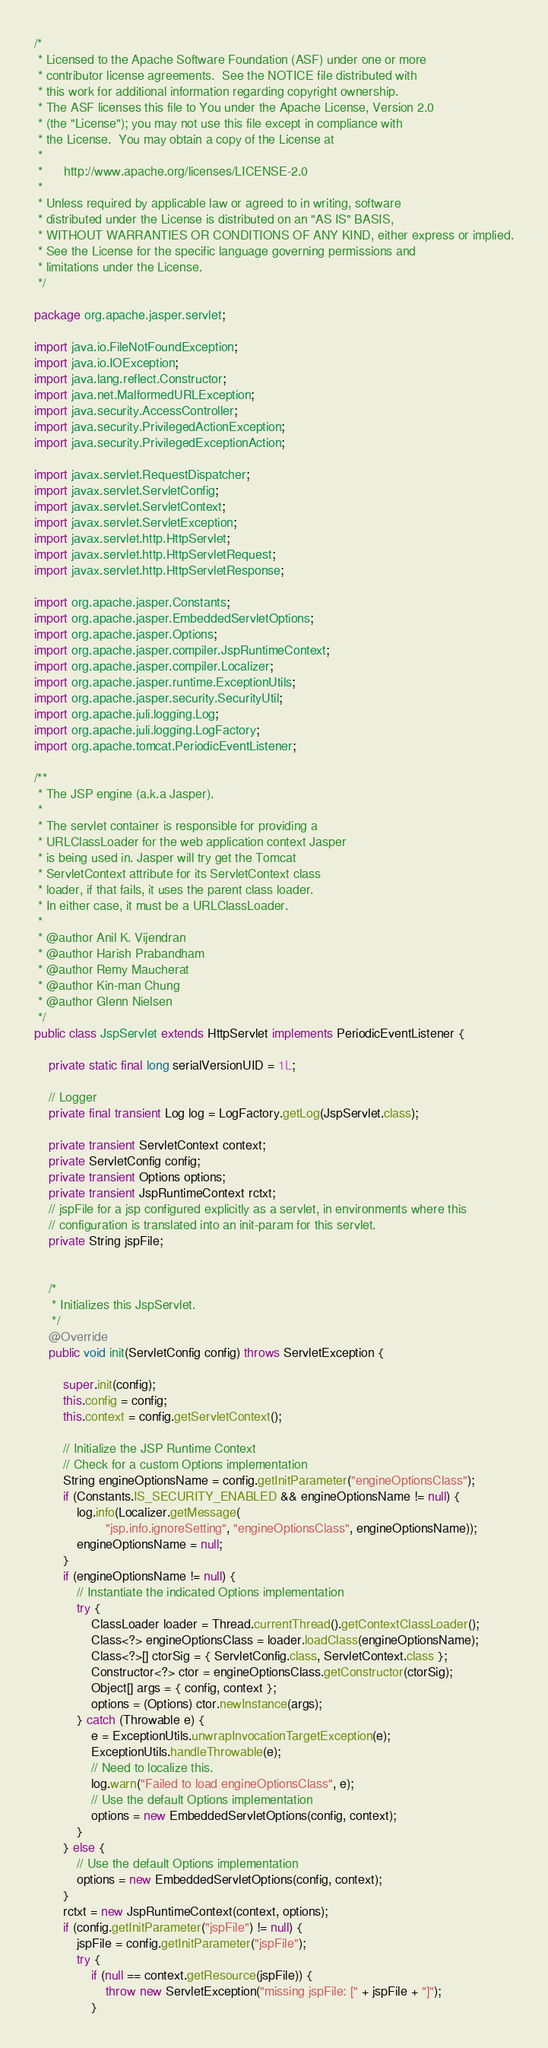<code> <loc_0><loc_0><loc_500><loc_500><_Java_>/*
 * Licensed to the Apache Software Foundation (ASF) under one or more
 * contributor license agreements.  See the NOTICE file distributed with
 * this work for additional information regarding copyright ownership.
 * The ASF licenses this file to You under the Apache License, Version 2.0
 * (the "License"); you may not use this file except in compliance with
 * the License.  You may obtain a copy of the License at
 *
 *      http://www.apache.org/licenses/LICENSE-2.0
 *
 * Unless required by applicable law or agreed to in writing, software
 * distributed under the License is distributed on an "AS IS" BASIS,
 * WITHOUT WARRANTIES OR CONDITIONS OF ANY KIND, either express or implied.
 * See the License for the specific language governing permissions and
 * limitations under the License.
 */

package org.apache.jasper.servlet;

import java.io.FileNotFoundException;
import java.io.IOException;
import java.lang.reflect.Constructor;
import java.net.MalformedURLException;
import java.security.AccessController;
import java.security.PrivilegedActionException;
import java.security.PrivilegedExceptionAction;

import javax.servlet.RequestDispatcher;
import javax.servlet.ServletConfig;
import javax.servlet.ServletContext;
import javax.servlet.ServletException;
import javax.servlet.http.HttpServlet;
import javax.servlet.http.HttpServletRequest;
import javax.servlet.http.HttpServletResponse;

import org.apache.jasper.Constants;
import org.apache.jasper.EmbeddedServletOptions;
import org.apache.jasper.Options;
import org.apache.jasper.compiler.JspRuntimeContext;
import org.apache.jasper.compiler.Localizer;
import org.apache.jasper.runtime.ExceptionUtils;
import org.apache.jasper.security.SecurityUtil;
import org.apache.juli.logging.Log;
import org.apache.juli.logging.LogFactory;
import org.apache.tomcat.PeriodicEventListener;

/**
 * The JSP engine (a.k.a Jasper).
 *
 * The servlet container is responsible for providing a
 * URLClassLoader for the web application context Jasper
 * is being used in. Jasper will try get the Tomcat
 * ServletContext attribute for its ServletContext class
 * loader, if that fails, it uses the parent class loader.
 * In either case, it must be a URLClassLoader.
 *
 * @author Anil K. Vijendran
 * @author Harish Prabandham
 * @author Remy Maucherat
 * @author Kin-man Chung
 * @author Glenn Nielsen
 */
public class JspServlet extends HttpServlet implements PeriodicEventListener {

    private static final long serialVersionUID = 1L;

    // Logger
    private final transient Log log = LogFactory.getLog(JspServlet.class);

    private transient ServletContext context;
    private ServletConfig config;
    private transient Options options;
    private transient JspRuntimeContext rctxt;
    // jspFile for a jsp configured explicitly as a servlet, in environments where this
    // configuration is translated into an init-param for this servlet.
    private String jspFile;


    /*
     * Initializes this JspServlet.
     */
    @Override
    public void init(ServletConfig config) throws ServletException {

        super.init(config);
        this.config = config;
        this.context = config.getServletContext();

        // Initialize the JSP Runtime Context
        // Check for a custom Options implementation
        String engineOptionsName = config.getInitParameter("engineOptionsClass");
        if (Constants.IS_SECURITY_ENABLED && engineOptionsName != null) {
            log.info(Localizer.getMessage(
                    "jsp.info.ignoreSetting", "engineOptionsClass", engineOptionsName));
            engineOptionsName = null;
        }
        if (engineOptionsName != null) {
            // Instantiate the indicated Options implementation
            try {
                ClassLoader loader = Thread.currentThread().getContextClassLoader();
                Class<?> engineOptionsClass = loader.loadClass(engineOptionsName);
                Class<?>[] ctorSig = { ServletConfig.class, ServletContext.class };
                Constructor<?> ctor = engineOptionsClass.getConstructor(ctorSig);
                Object[] args = { config, context };
                options = (Options) ctor.newInstance(args);
            } catch (Throwable e) {
                e = ExceptionUtils.unwrapInvocationTargetException(e);
                ExceptionUtils.handleThrowable(e);
                // Need to localize this.
                log.warn("Failed to load engineOptionsClass", e);
                // Use the default Options implementation
                options = new EmbeddedServletOptions(config, context);
            }
        } else {
            // Use the default Options implementation
            options = new EmbeddedServletOptions(config, context);
        }
        rctxt = new JspRuntimeContext(context, options);
        if (config.getInitParameter("jspFile") != null) {
            jspFile = config.getInitParameter("jspFile");
            try {
                if (null == context.getResource(jspFile)) {
                    throw new ServletException("missing jspFile: [" + jspFile + "]");
                }</code> 